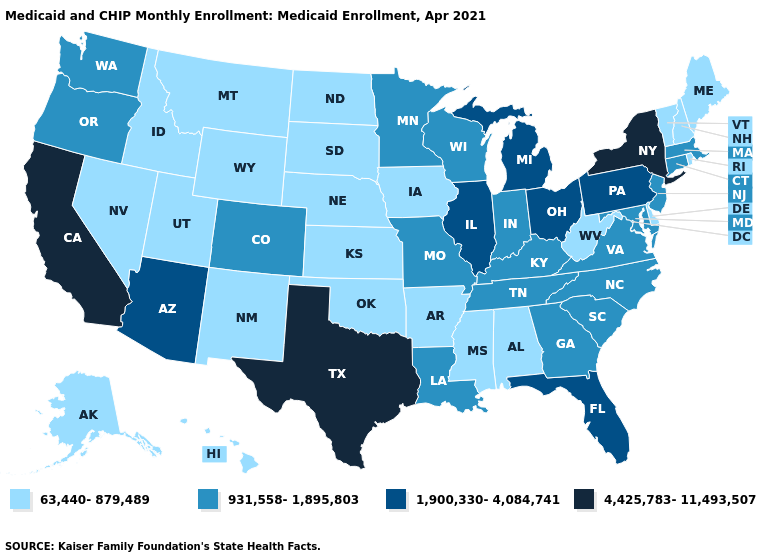Among the states that border South Dakota , which have the lowest value?
Concise answer only. Iowa, Montana, Nebraska, North Dakota, Wyoming. What is the value of Tennessee?
Keep it brief. 931,558-1,895,803. Does the first symbol in the legend represent the smallest category?
Concise answer only. Yes. How many symbols are there in the legend?
Write a very short answer. 4. What is the value of Arkansas?
Quick response, please. 63,440-879,489. What is the value of New Jersey?
Concise answer only. 931,558-1,895,803. What is the highest value in the USA?
Concise answer only. 4,425,783-11,493,507. What is the highest value in the USA?
Be succinct. 4,425,783-11,493,507. What is the lowest value in the West?
Write a very short answer. 63,440-879,489. Does New York have the highest value in the Northeast?
Concise answer only. Yes. Does the map have missing data?
Give a very brief answer. No. Name the states that have a value in the range 4,425,783-11,493,507?
Quick response, please. California, New York, Texas. Does the first symbol in the legend represent the smallest category?
Concise answer only. Yes. Name the states that have a value in the range 931,558-1,895,803?
Quick response, please. Colorado, Connecticut, Georgia, Indiana, Kentucky, Louisiana, Maryland, Massachusetts, Minnesota, Missouri, New Jersey, North Carolina, Oregon, South Carolina, Tennessee, Virginia, Washington, Wisconsin. Which states have the highest value in the USA?
Give a very brief answer. California, New York, Texas. 